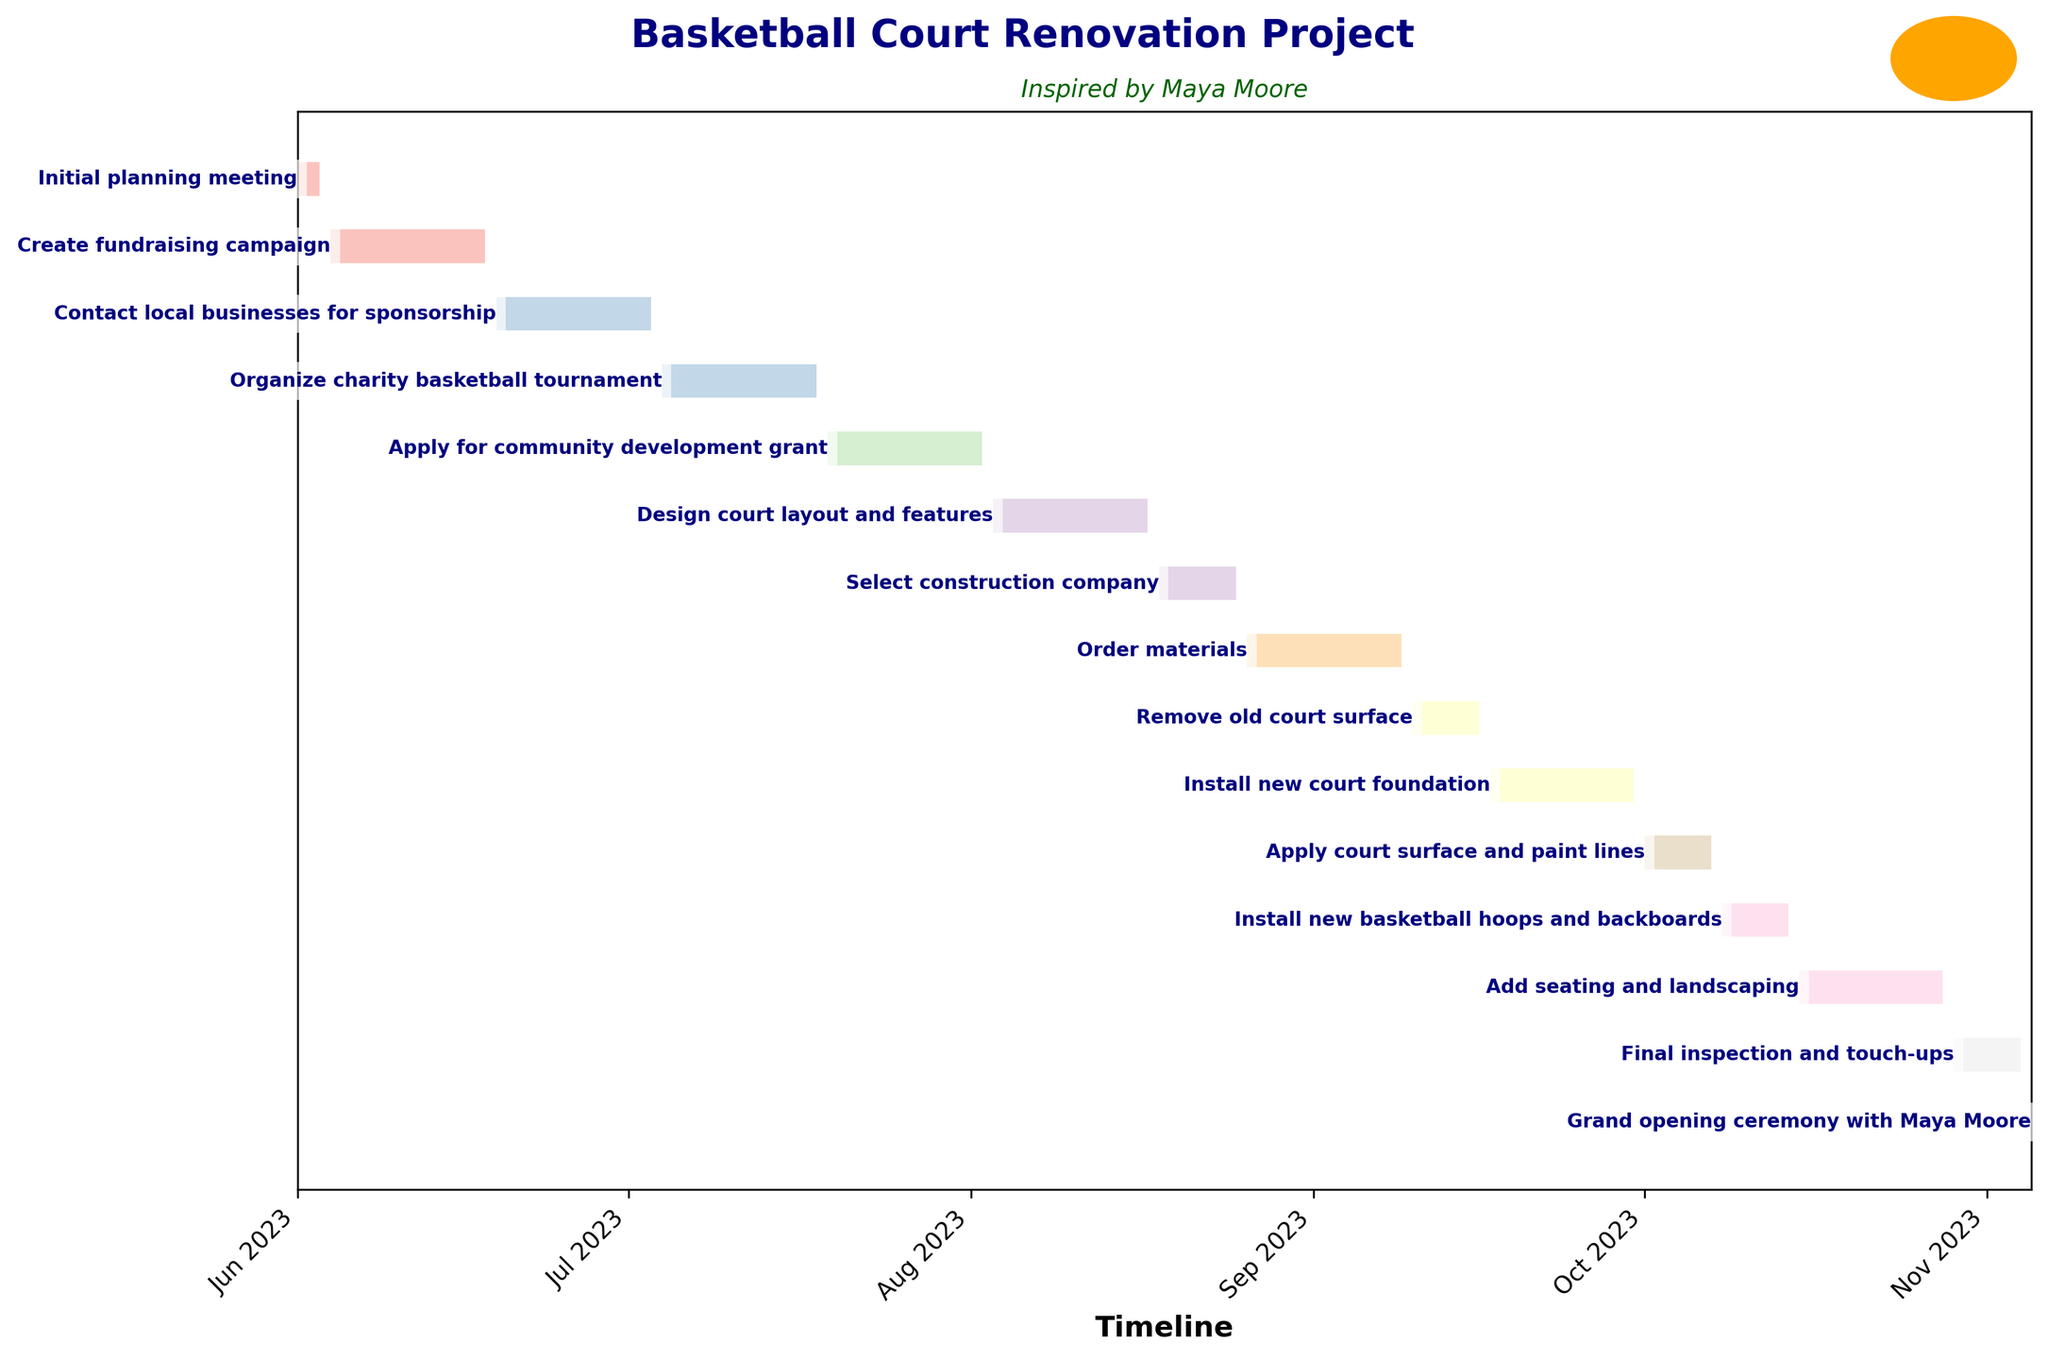What is the duration of the "Create fundraising campaign" task? The Gantt chart shows the "Create fundraising campaign" task along with its start and end dates. The duration is calculated as the difference between the start date (June 4, 2023) and the end date (June 18, 2023), which is given as 15 days.
Answer: 15 days Which task takes the longest time to complete? By examining the Gantt chart, you can compare the lengths of all the tasks. The task "Add seating and landscaping" starts on October 15, 2023, and ends on October 28, 2023, lasting 14 days, which appears to be the longest single task.
Answer: Add seating and landscaping How many tasks are scheduled in the month of July 2023? For this, you examine the timeline and count the number of tasks whose timelines fall within July 2023. The tasks are "Contact local businesses for sponsorship," "Organize charity basketball tournament," and "Apply for community development grant," totaling three tasks for July.
Answer: 3 tasks Which tasks overlap with the "Order materials" task? The Gantt chart will show the timeline for "Order materials" from August 26, 2023, to September 9, 2023. You then look to see other tasks within this period. "Select construction company" (Aug 18 - Aug 25) ends just before, and "Remove old court surface" (Sept 10 - Sept 16) starts right after, so there are no overlapping tasks.
Answer: None What is the gap between the end of "Initial planning meeting" and the start of "Create fundraising campaign"? "Initial planning meeting" ends on June 3, 2023, and "Create fundraising campaign" starts on June 4, 2023. Subtracting these dates reveals there's no gap between these tasks.
Answer: No gap When is the "Grand opening ceremony with Maya Moore" scheduled? On the Gantt chart, you can locate the "Grand opening ceremony with Maya Moore" task, which is scheduled for November 5, 2023, as a one-day event.
Answer: November 5, 2023 What is the combined duration of the "Install new court foundation" and "Apply court surface and paint lines"? "Install new court foundation" lasts from Sept 17 to Sept 30 (14 days), and "Apply court surface and paint lines" lasts from Oct 1 to Oct 7 (7 days). Adding both durations, the combined total is 14 + 7.
Answer: 21 days Which task starts immediately after "Design court layout and features"? The task "Select construction company" starts on August 18, 2023, the day after "Design court layout and features" ends on August 17, 2023.
Answer: Select construction company How many tasks are part of the design phase? To find this, examine the task names. Only "Design court layout and features" is related to the design, indicating there is one task in the design phase.
Answer: 1 task 